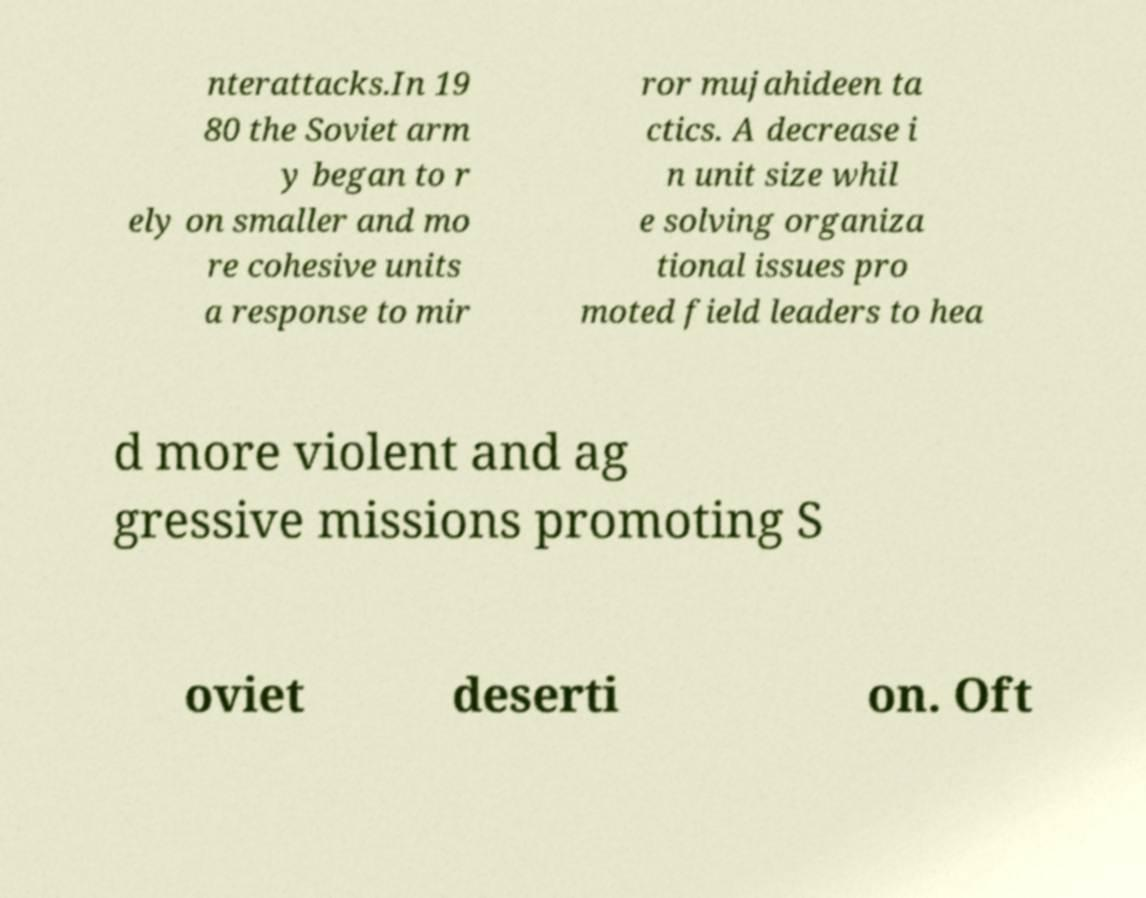What messages or text are displayed in this image? I need them in a readable, typed format. nterattacks.In 19 80 the Soviet arm y began to r ely on smaller and mo re cohesive units a response to mir ror mujahideen ta ctics. A decrease i n unit size whil e solving organiza tional issues pro moted field leaders to hea d more violent and ag gressive missions promoting S oviet deserti on. Oft 